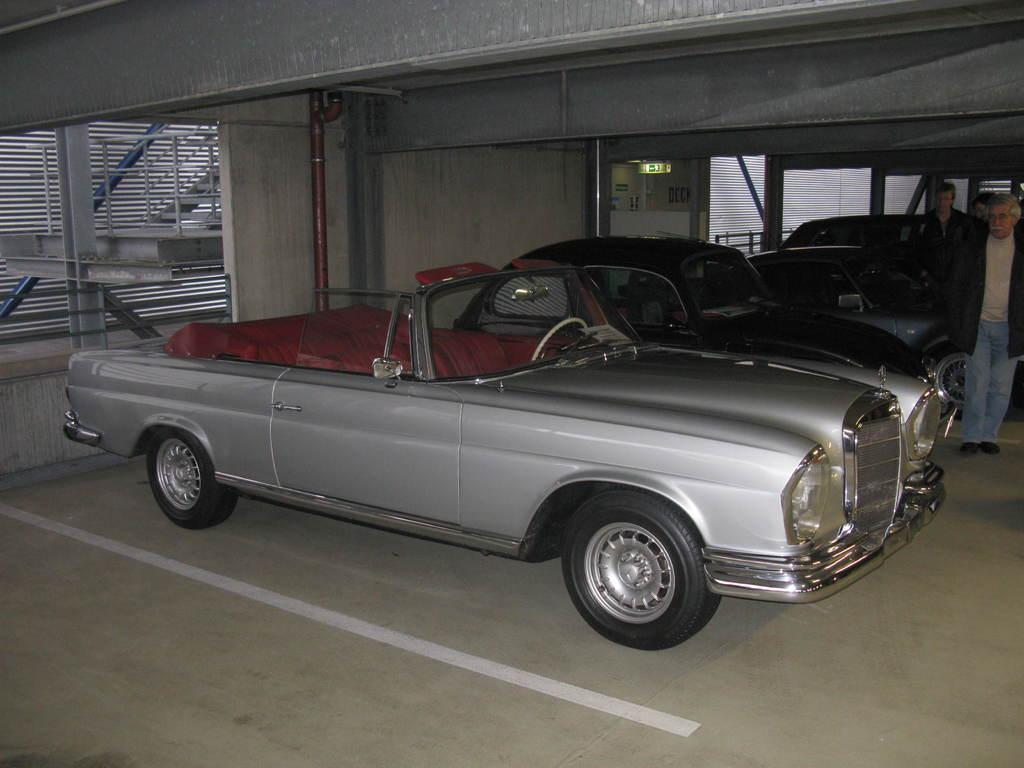Please provide a concise description of this image. In this picture I see the cars in front and I see few people and I see the path. In the background I see the wall and I see the bars on the left top of this image. 